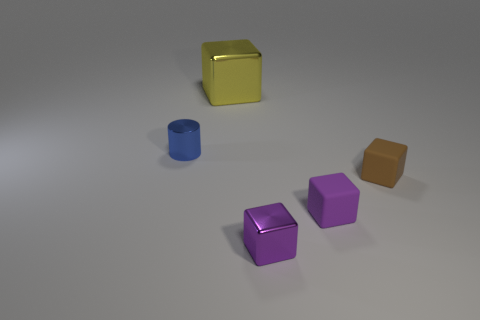Subtract all cyan blocks. Subtract all gray spheres. How many blocks are left? 4 Add 3 red metal spheres. How many objects exist? 8 Subtract all cylinders. How many objects are left? 4 Subtract 0 yellow cylinders. How many objects are left? 5 Subtract all big cylinders. Subtract all large yellow blocks. How many objects are left? 4 Add 1 large metallic things. How many large metallic things are left? 2 Add 2 tiny brown rubber blocks. How many tiny brown rubber blocks exist? 3 